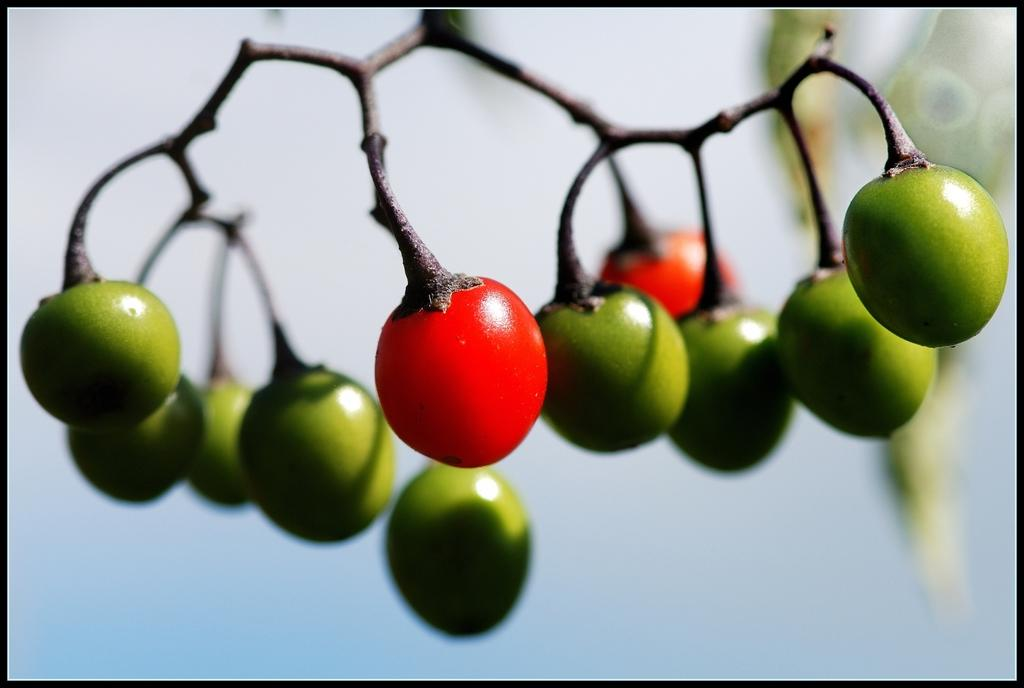What type of fruit is visible in the image? There are cherries in the image. What else can be seen in the image besides the cherries? There are stems of a tree in the image. How would you describe the background of the image? The background of the image is blurred. What is the color of the border surrounding the image? The image has a black border. How does the person in the image say good-bye to the cherries? There is no person present in the image, so it is not possible to determine how they would say good-bye to the cherries. 